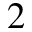Convert formula to latex. <formula><loc_0><loc_0><loc_500><loc_500>2</formula> 